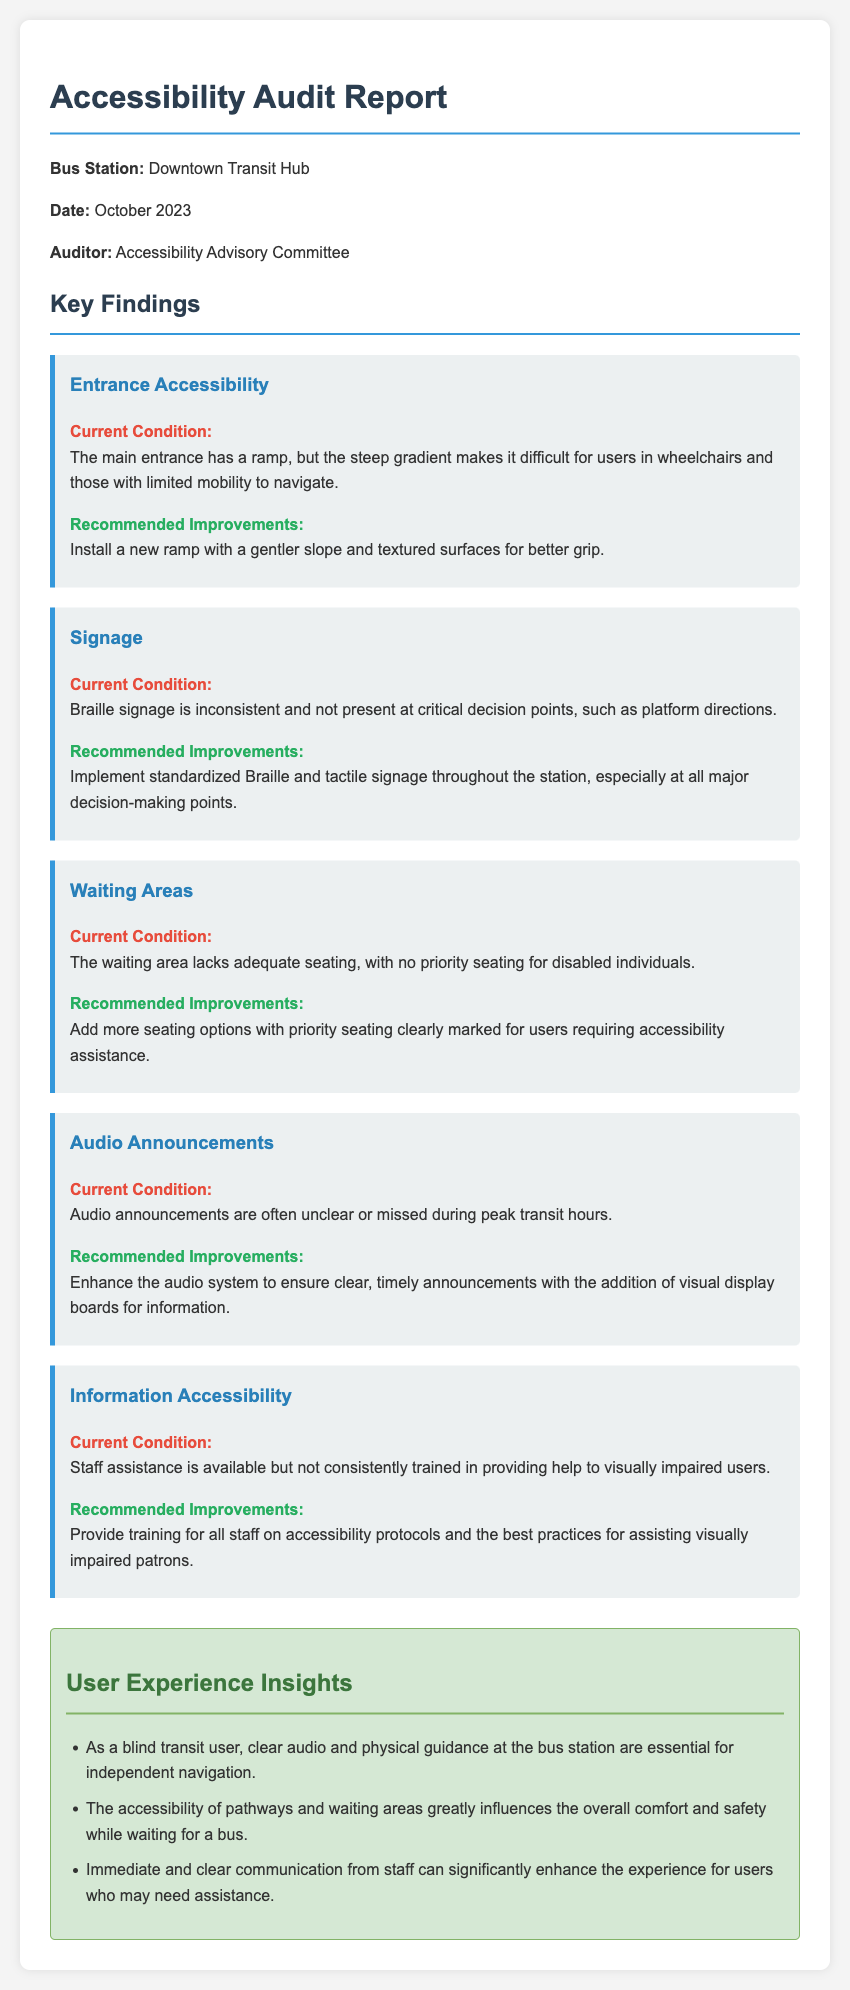What is the name of the bus station? The document specifies that the name of the bus station being audited is the Downtown Transit Hub.
Answer: Downtown Transit Hub When was the accessibility audit conducted? The date of the audit is mentioned clearly in the document.
Answer: October 2023 Who conducted the audit? The document states that the audit was conducted by the Accessibility Advisory Committee.
Answer: Accessibility Advisory Committee What is the current condition of the entrance accessibility? The document describes the main entrance's ramp and its steep gradient making it difficult for users.
Answer: Steep gradient What is one recommended improvement for signage? The document suggests implementing standardized Braille and tactile signage throughout the station.
Answer: Standardized Braille signage How many insights are provided in the user experience section? The user experience section lists specific user insights, and the document cites three.
Answer: Three What improvement is suggested for the audio announcements? The document recommends enhancing the audio system for clearer announcements.
Answer: Enhance audio system What lack of amenity is noted in the waiting areas? The document mentions a deficiency in the availability of adequate seating in the waiting area.
Answer: Lack of adequate seating What is a current issue mentioned regarding staff assistance? The document highlights that staff assistance is not consistently trained for visually impaired users.
Answer: Not consistently trained 